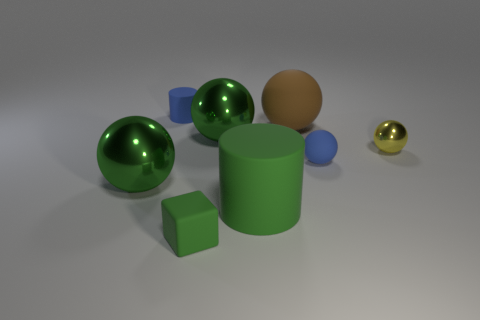Subtract all big balls. How many balls are left? 2 Subtract all blue cylinders. How many cylinders are left? 1 Add 1 big brown shiny blocks. How many objects exist? 9 Subtract 4 balls. How many balls are left? 1 Subtract all cubes. How many objects are left? 7 Subtract all green cubes. How many green cylinders are left? 1 Add 7 yellow objects. How many yellow objects are left? 8 Add 2 yellow balls. How many yellow balls exist? 3 Subtract 1 green balls. How many objects are left? 7 Subtract all gray cubes. Subtract all green balls. How many cubes are left? 1 